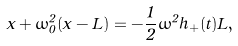Convert formula to latex. <formula><loc_0><loc_0><loc_500><loc_500>\ddot { x } + \omega _ { 0 } ^ { 2 } ( x - L ) = - \frac { 1 } { 2 } \omega ^ { 2 } h _ { + } ( t ) L ,</formula> 